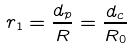<formula> <loc_0><loc_0><loc_500><loc_500>r _ { 1 } = \frac { d _ { p } } { R } = \frac { d _ { c } } { R _ { 0 } }</formula> 